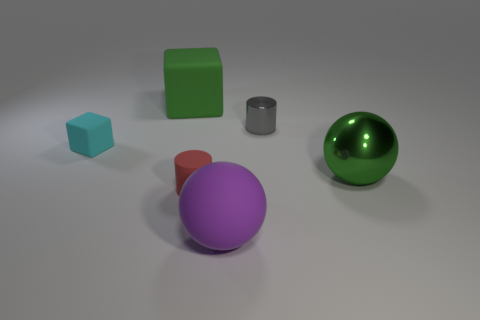How might the lighting in the scene affect the way we perceive the color of the objects? The lighting in the scene is soft and diffuse, with no harsh shadows, ensuring consistent exposure across the objects which allows their colors to be perceived without significant alteration. However, areas of specular reflection on the shiny objects may appear brighter and potentially affect our perception of their true colors. Lighter surfaces may reflect more light to the viewer, making their colors appear slightly lighter, while the matte textures may make the true colors of the objects appear deeper. 